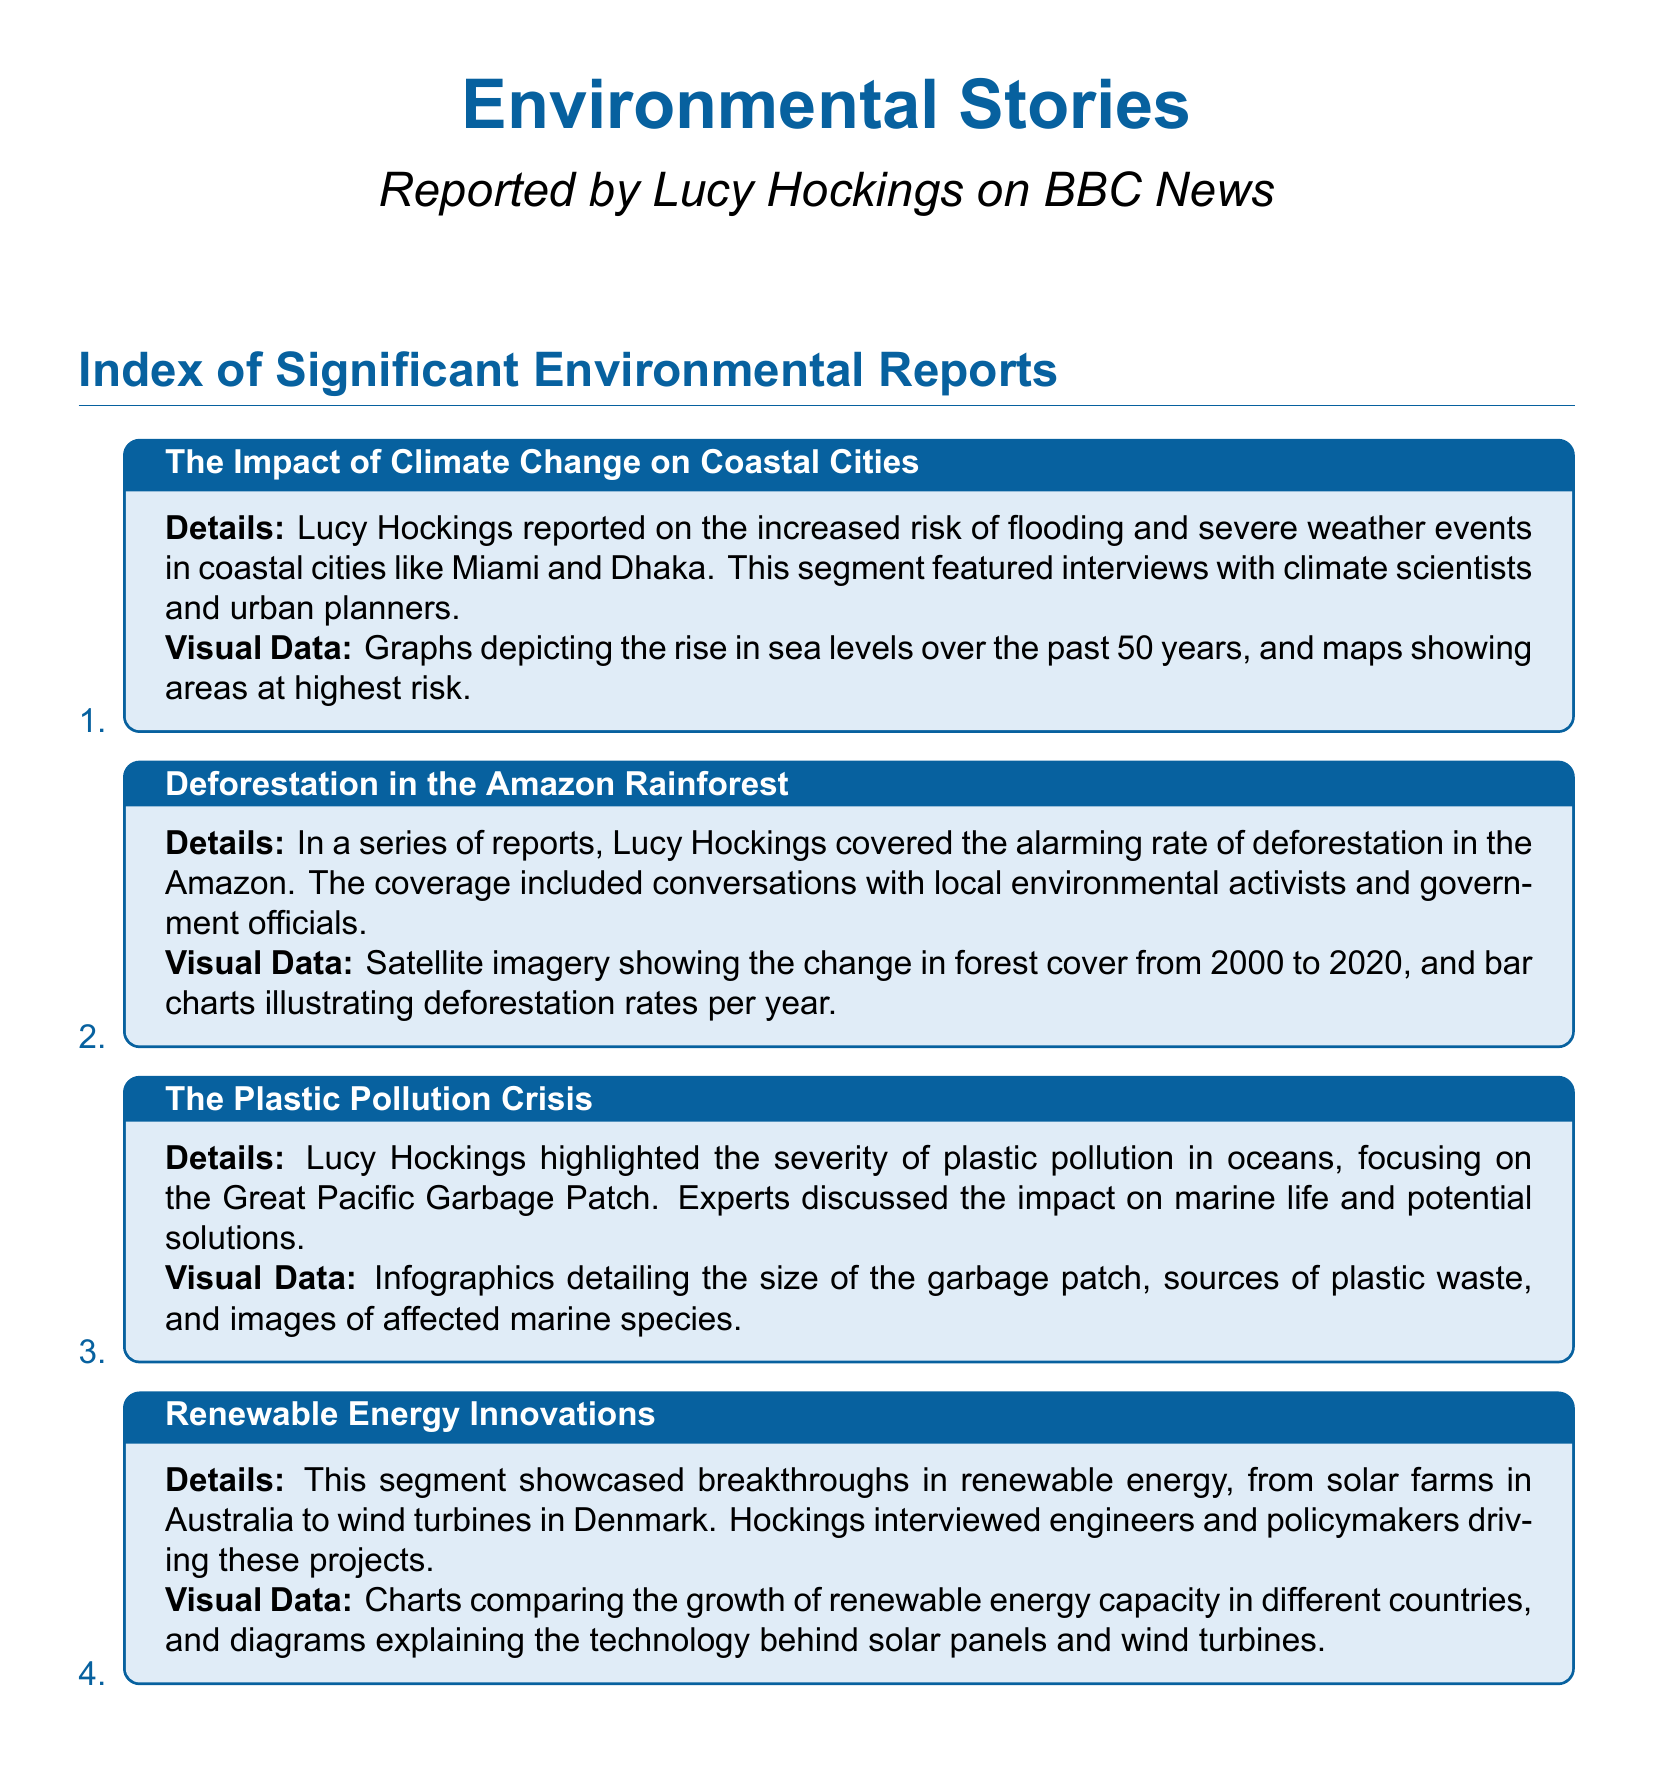What coastal cities were reported on? The report specifically mentioned coastal cities like Miami and Dhaka as examples of areas facing flooding risks.
Answer: Miami and Dhaka What time span does the deforestation data cover? The satellite imagery in the report showed changes in forest cover specifically from the year 2000 to 2020.
Answer: 2000 to 2020 What was a focal point of the pollution crisis segment? The Great Pacific Garbage Patch was highlighted as a significant area affected by plastic pollution in oceans.
Answer: Great Pacific Garbage Patch What type of energy innovations were highlighted? The segment prominently showcased breakthroughs in renewable energy, including solar and wind technologies.
Answer: Renewable energy What visual data depicted the rise in sea levels? Graphs were used to illustrate the increase in sea levels over a significant 50-year period.
Answer: Graphs How many reports were mentioned regarding deforestation? The document describes a series of reports that Lucy Hockings covered in total regarding deforestation.
Answer: A series Which country is associated with the wind turbine innovations? Denmark was specifically mentioned as the location for wind turbine innovations.
Answer: Denmark What do the infographics detail? Infographics in the plastic pollution segment detailed various aspects including the size of the garbage patch and sources of plastic waste.
Answer: Size of the garbage patch Which stakeholders were interviewed in the renewable energy segment? Engineers and policymakers were featured as the key stakeholders interviewed about renewable energy projects.
Answer: Engineers and policymakers 